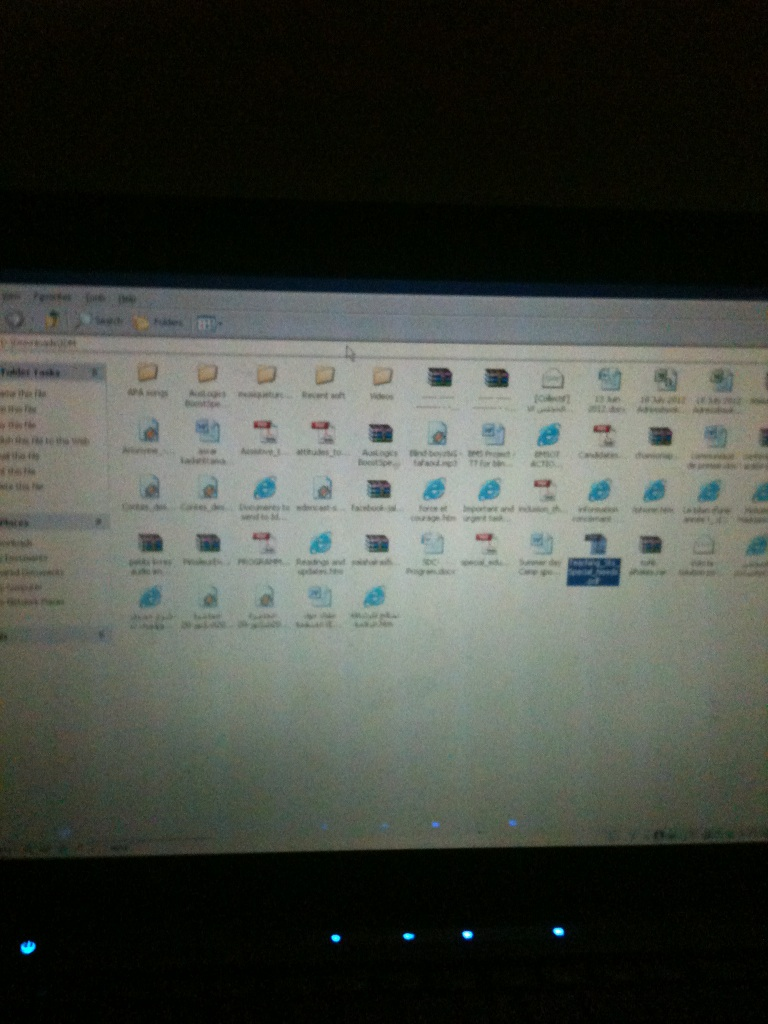If you had to access one of these files for a treasure hunt, where would you start? For a treasure hunt, I would start by opening files or icons with unique or unfamiliar names first, as they are likely to hold more interesting or unexpected content. Files with prefixes like 'mystery,' 'secret,' or anything that stands out from the usual names would be good candidates. Exploring folders or documents that are less frequently accessed might reveal hidden or special information set aside for such an event. Can you think of an imaginative scenario involving these files? Sure! Imagine these files are map pieces and clues in a digital quest set in the virtual world of this computer. Each document and icon represents levels you must navigate, solving puzzles hidden within documents and defeating rogue programs or viruses guarding critical information. Successfully accessing each file reveals part of a grand treasure, like unlocking a segmented code to a digital vault holding precious artifacts, secrets from the owner's life, or even a virtual treasure chest brimming with cryptographic tokens! 